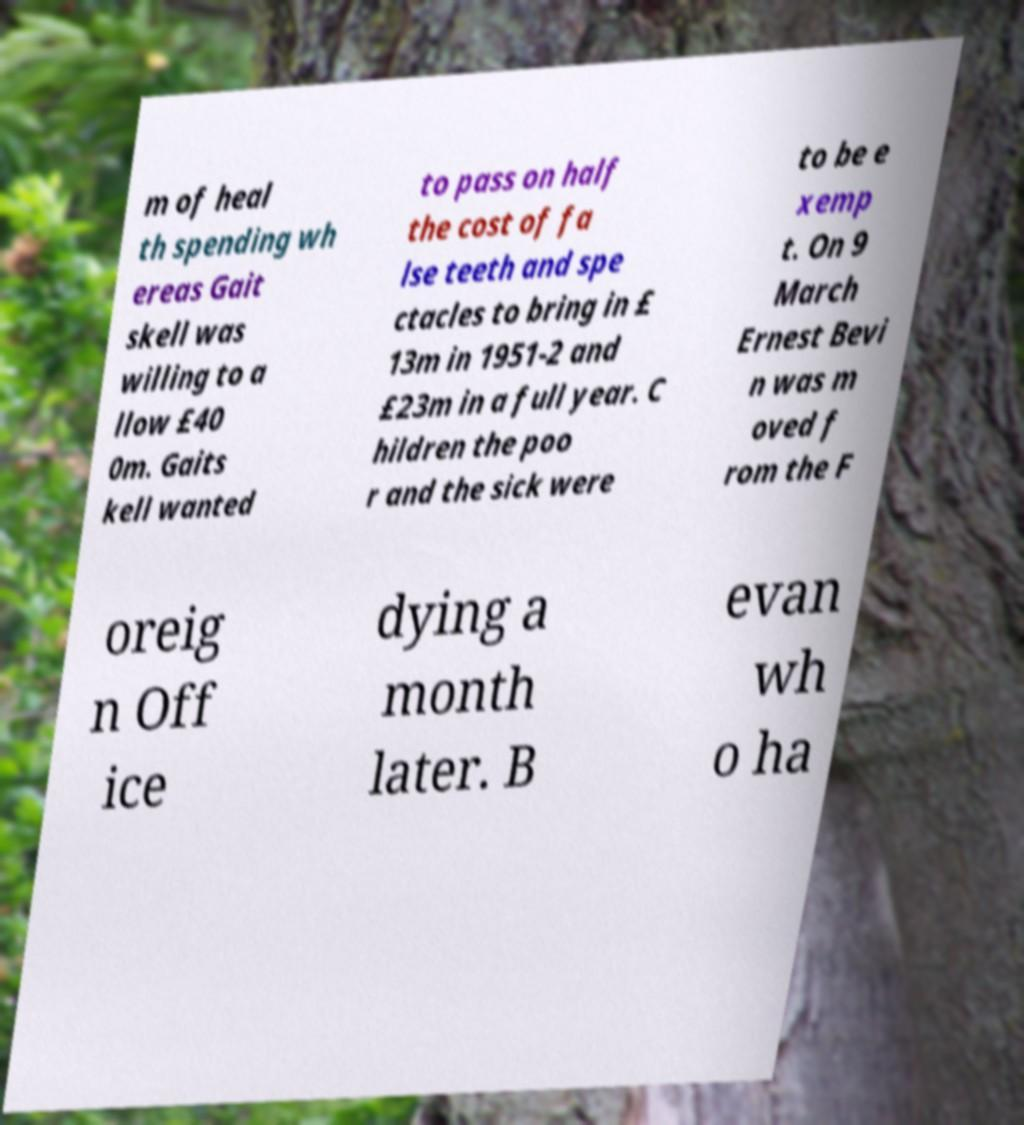There's text embedded in this image that I need extracted. Can you transcribe it verbatim? m of heal th spending wh ereas Gait skell was willing to a llow £40 0m. Gaits kell wanted to pass on half the cost of fa lse teeth and spe ctacles to bring in £ 13m in 1951-2 and £23m in a full year. C hildren the poo r and the sick were to be e xemp t. On 9 March Ernest Bevi n was m oved f rom the F oreig n Off ice dying a month later. B evan wh o ha 